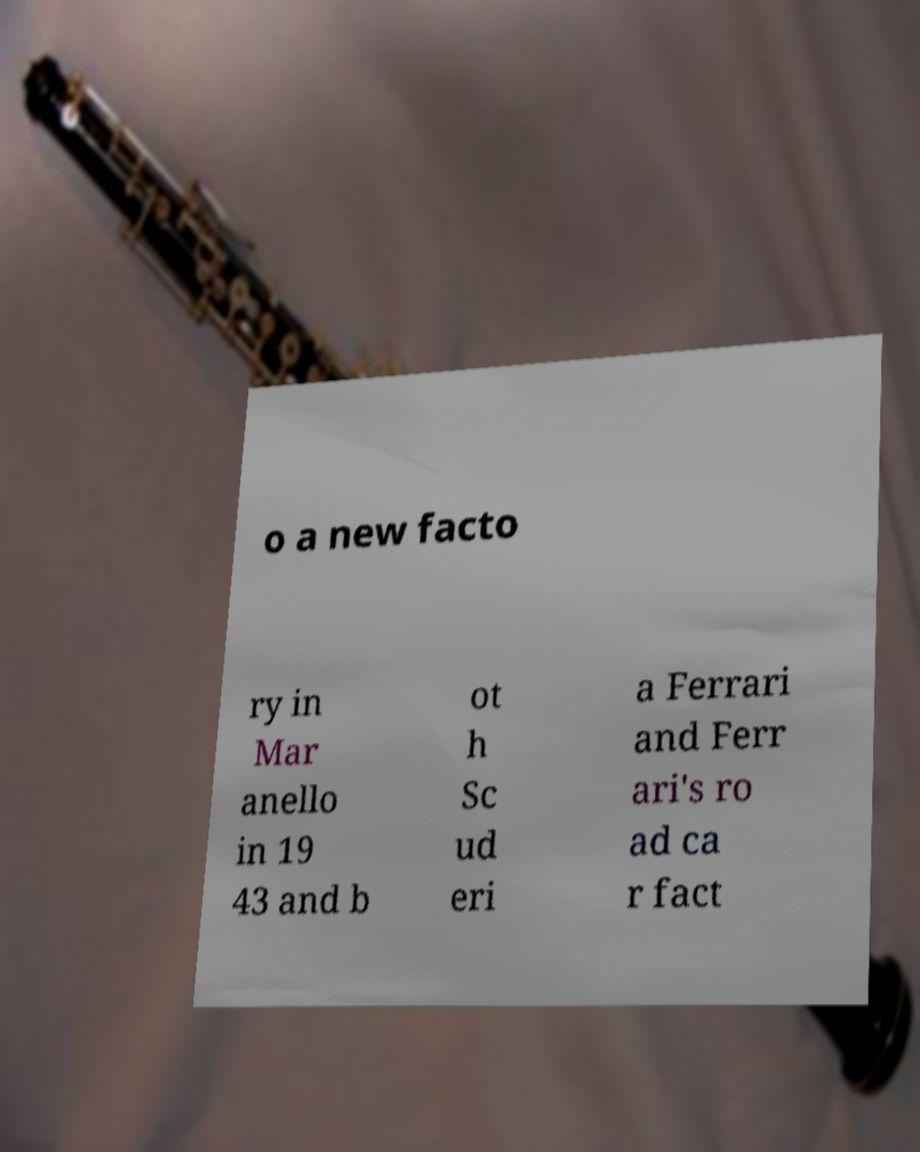Could you assist in decoding the text presented in this image and type it out clearly? o a new facto ry in Mar anello in 19 43 and b ot h Sc ud eri a Ferrari and Ferr ari's ro ad ca r fact 